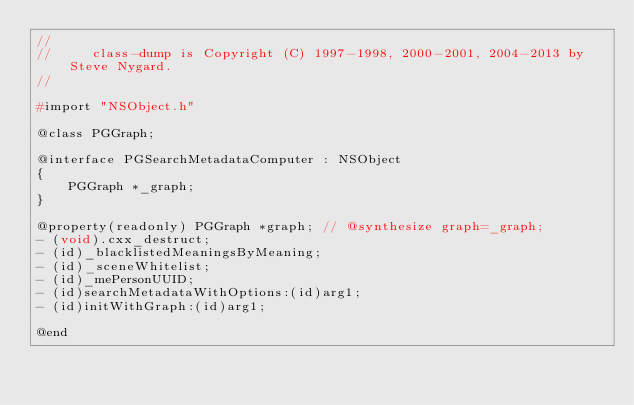Convert code to text. <code><loc_0><loc_0><loc_500><loc_500><_C_>//
//     class-dump is Copyright (C) 1997-1998, 2000-2001, 2004-2013 by Steve Nygard.
//

#import "NSObject.h"

@class PGGraph;

@interface PGSearchMetadataComputer : NSObject
{
    PGGraph *_graph;
}

@property(readonly) PGGraph *graph; // @synthesize graph=_graph;
- (void).cxx_destruct;
- (id)_blacklistedMeaningsByMeaning;
- (id)_sceneWhitelist;
- (id)_mePersonUUID;
- (id)searchMetadataWithOptions:(id)arg1;
- (id)initWithGraph:(id)arg1;

@end

</code> 